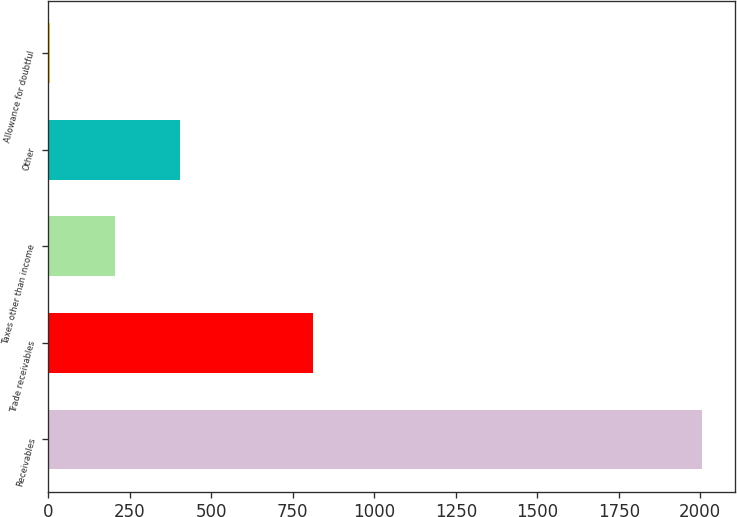Convert chart to OTSL. <chart><loc_0><loc_0><loc_500><loc_500><bar_chart><fcel>Receivables<fcel>Trade receivables<fcel>Taxes other than income<fcel>Other<fcel>Allowance for doubtful<nl><fcel>2006<fcel>811<fcel>204.2<fcel>404.4<fcel>4<nl></chart> 